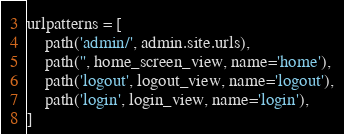<code> <loc_0><loc_0><loc_500><loc_500><_Python_>urlpatterns = [
    path('admin/', admin.site.urls),
    path('', home_screen_view, name='home'),
    path('logout', logout_view, name='logout'),
    path('login', login_view, name='login'),
]
</code> 